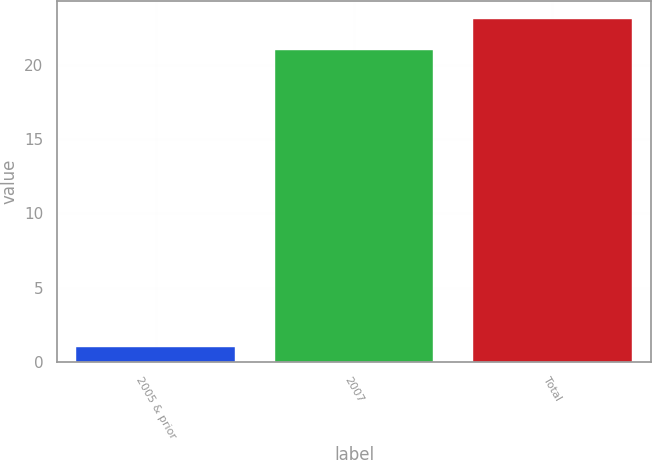Convert chart. <chart><loc_0><loc_0><loc_500><loc_500><bar_chart><fcel>2005 & prior<fcel>2007<fcel>Total<nl><fcel>1<fcel>21<fcel>23.1<nl></chart> 